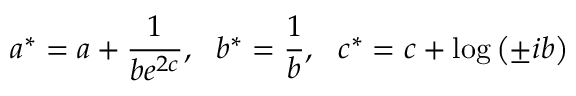Convert formula to latex. <formula><loc_0><loc_0><loc_500><loc_500>a ^ { * } = a + \frac { 1 } { b e ^ { 2 c } } , \, b ^ { * } = \frac { 1 } { b } , \, c ^ { * } = c + \log \left ( \pm i b \right )</formula> 